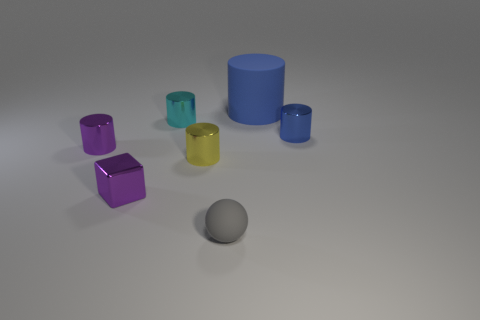What is the size of the gray object that is made of the same material as the big blue object?
Provide a succinct answer. Small. How many metallic objects have the same shape as the large blue matte object?
Ensure brevity in your answer.  4. There is a tiny metal cylinder that is right of the yellow metallic cylinder; is it the same color as the rubber cylinder?
Offer a very short reply. Yes. What number of objects are on the right side of the rubber thing in front of the rubber thing that is behind the tiny cyan shiny object?
Your response must be concise. 2. How many tiny objects are behind the blue metal object and in front of the blue metal thing?
Give a very brief answer. 0. The small shiny object that is the same color as the cube is what shape?
Offer a very short reply. Cylinder. Is there any other thing that is made of the same material as the large blue cylinder?
Your response must be concise. Yes. Are the small purple cylinder and the gray object made of the same material?
Keep it short and to the point. No. The rubber object right of the tiny gray rubber ball that is on the left side of the small shiny thing that is to the right of the gray rubber object is what shape?
Keep it short and to the point. Cylinder. Are there fewer small blocks that are on the right side of the yellow metal object than small cyan shiny things behind the small cyan object?
Make the answer very short. No. 